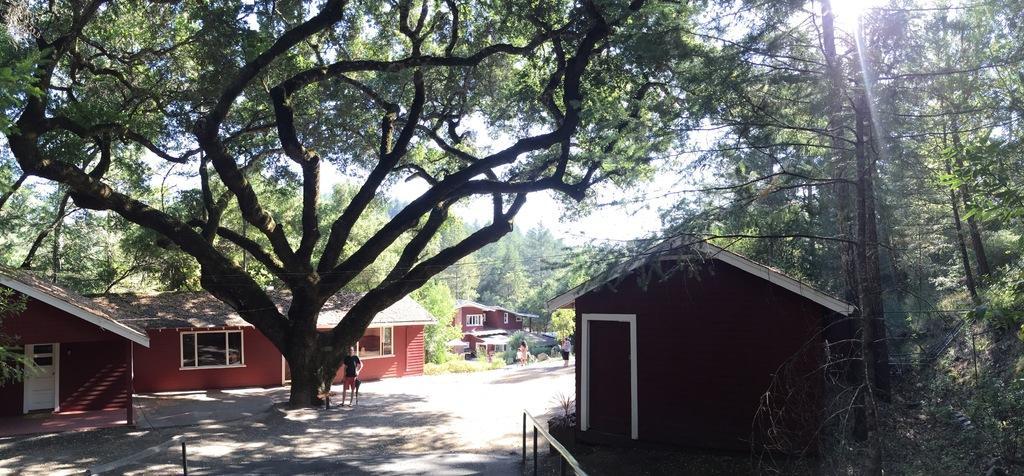Please provide a concise description of this image. In this image we can see the houses, trees, electrical poles with wires. We can also see the persons on the road. Image also consists of the barrier rods, plants, grass and also the sky. 